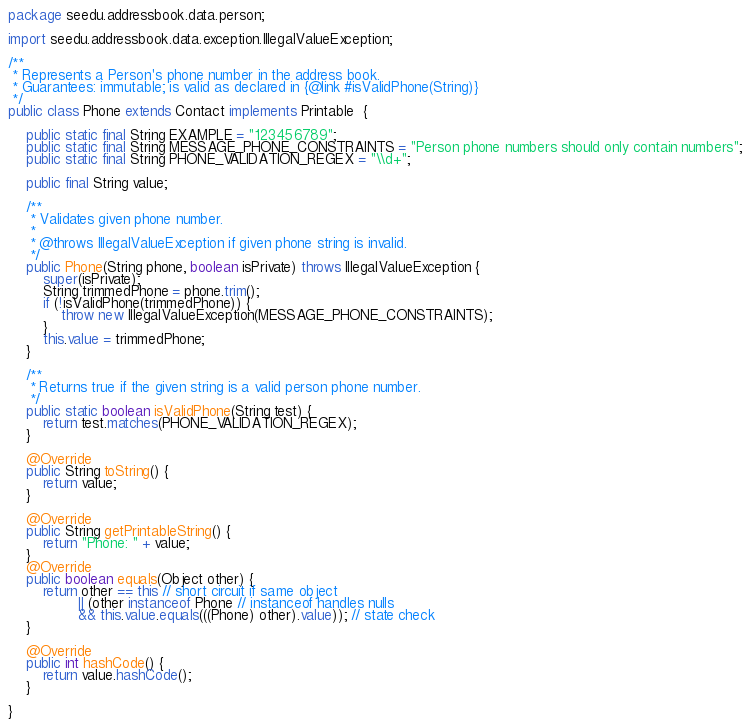Convert code to text. <code><loc_0><loc_0><loc_500><loc_500><_Java_>package seedu.addressbook.data.person;

import seedu.addressbook.data.exception.IllegalValueException;

/**
 * Represents a Person's phone number in the address book.
 * Guarantees: immutable; is valid as declared in {@link #isValidPhone(String)}
 */
public class Phone extends Contact implements Printable  {

    public static final String EXAMPLE = "123456789";
    public static final String MESSAGE_PHONE_CONSTRAINTS = "Person phone numbers should only contain numbers";
    public static final String PHONE_VALIDATION_REGEX = "\\d+";

    public final String value;

    /**
     * Validates given phone number.
     *
     * @throws IllegalValueException if given phone string is invalid.
     */
    public Phone(String phone, boolean isPrivate) throws IllegalValueException {
        super(isPrivate);
        String trimmedPhone = phone.trim();
        if (!isValidPhone(trimmedPhone)) {
            throw new IllegalValueException(MESSAGE_PHONE_CONSTRAINTS);
        }
        this.value = trimmedPhone;
    }

    /**
     * Returns true if the given string is a valid person phone number.
     */
    public static boolean isValidPhone(String test) {
        return test.matches(PHONE_VALIDATION_REGEX);
    }

    @Override
    public String toString() {
        return value;
    }

    @Override
    public String getPrintableString() {
        return "Phone: " + value;
    }
    @Override
    public boolean equals(Object other) {
        return other == this // short circuit if same object
                || (other instanceof Phone // instanceof handles nulls
                && this.value.equals(((Phone) other).value)); // state check
    }

    @Override
    public int hashCode() {
        return value.hashCode();
    }

}
</code> 